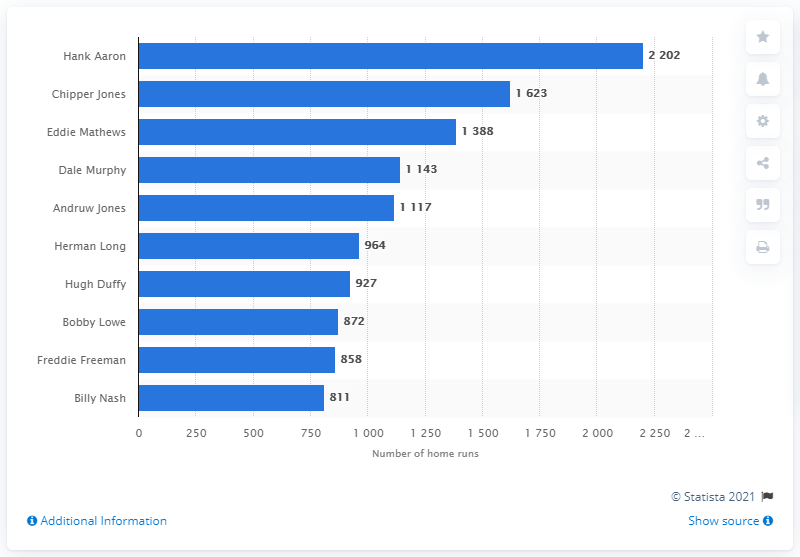Give some essential details in this illustration. Hank Aaron holds the record for the most RBI in the history of the Atlanta Braves franchise. 